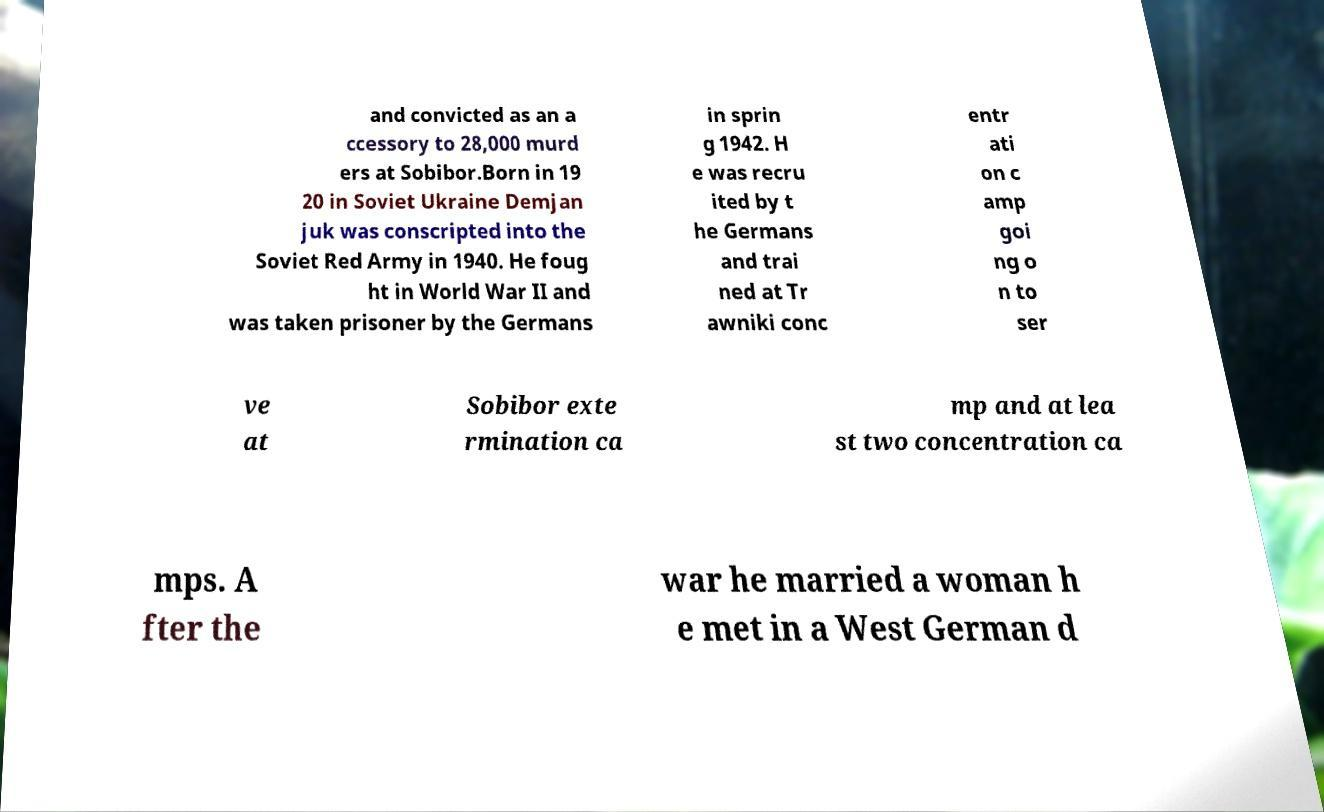Could you extract and type out the text from this image? and convicted as an a ccessory to 28,000 murd ers at Sobibor.Born in 19 20 in Soviet Ukraine Demjan juk was conscripted into the Soviet Red Army in 1940. He foug ht in World War II and was taken prisoner by the Germans in sprin g 1942. H e was recru ited by t he Germans and trai ned at Tr awniki conc entr ati on c amp goi ng o n to ser ve at Sobibor exte rmination ca mp and at lea st two concentration ca mps. A fter the war he married a woman h e met in a West German d 